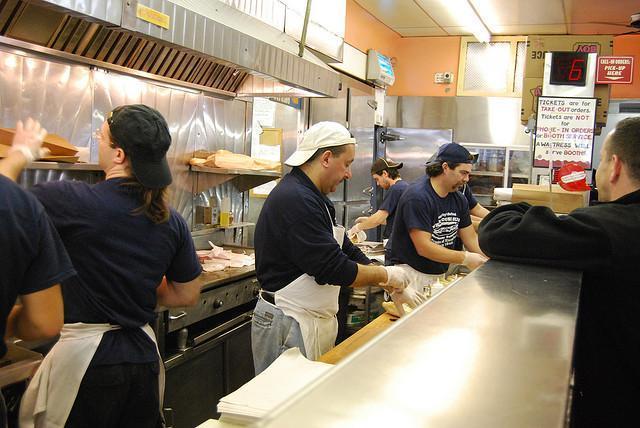How many people are in the photo?
Give a very brief answer. 6. 